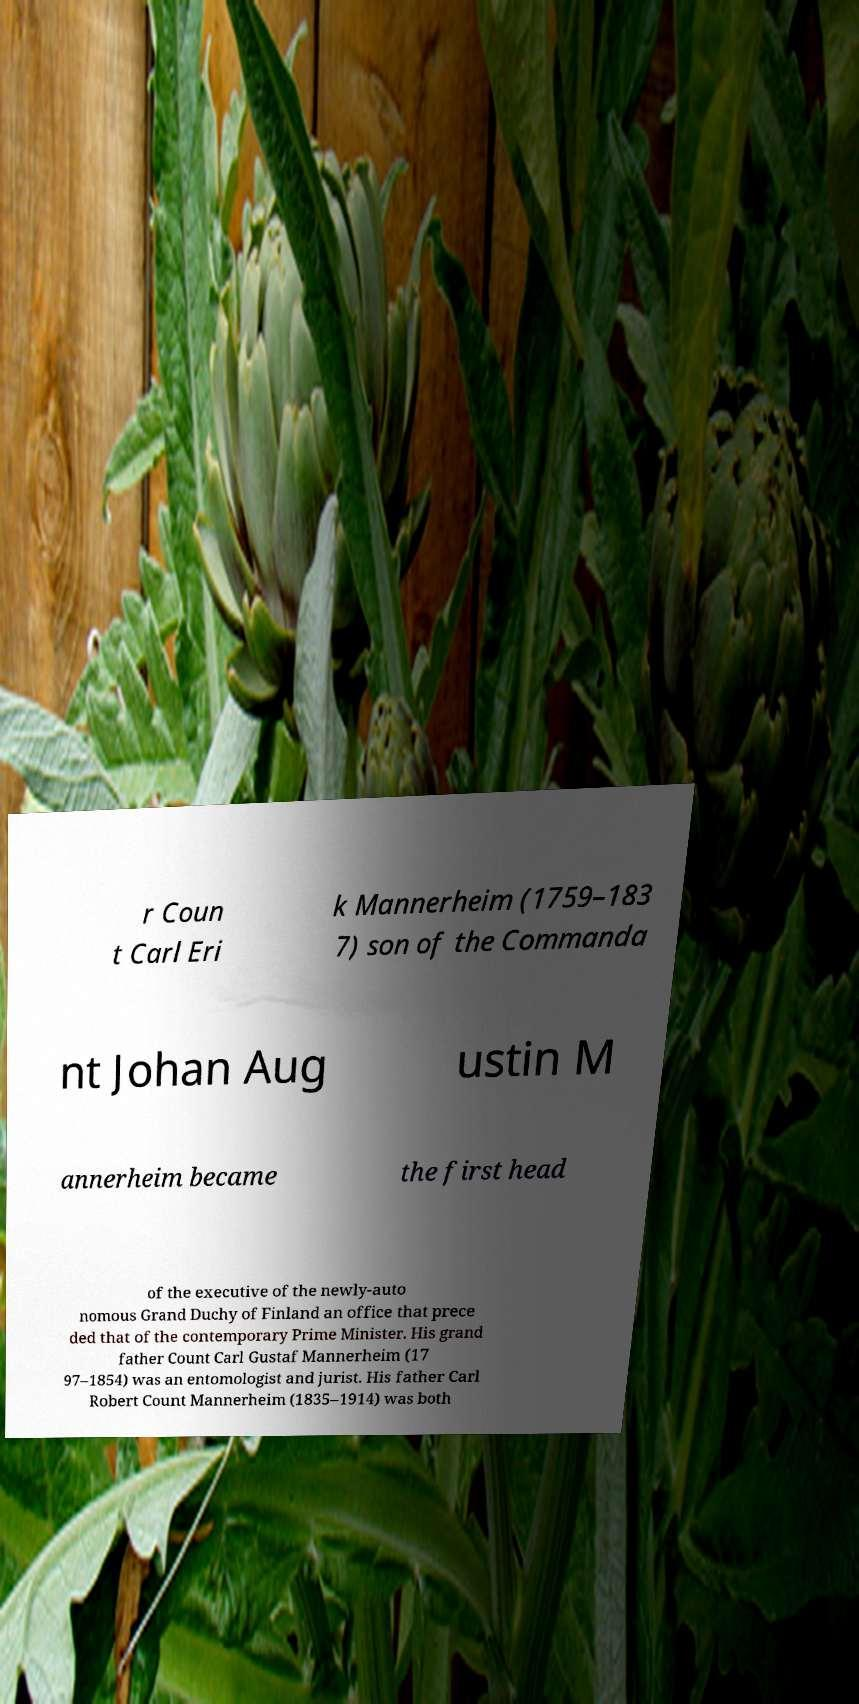Can you accurately transcribe the text from the provided image for me? r Coun t Carl Eri k Mannerheim (1759–183 7) son of the Commanda nt Johan Aug ustin M annerheim became the first head of the executive of the newly-auto nomous Grand Duchy of Finland an office that prece ded that of the contemporary Prime Minister. His grand father Count Carl Gustaf Mannerheim (17 97–1854) was an entomologist and jurist. His father Carl Robert Count Mannerheim (1835–1914) was both 